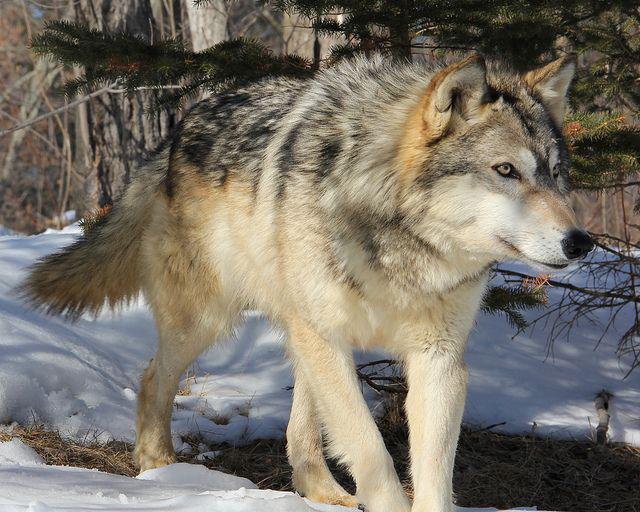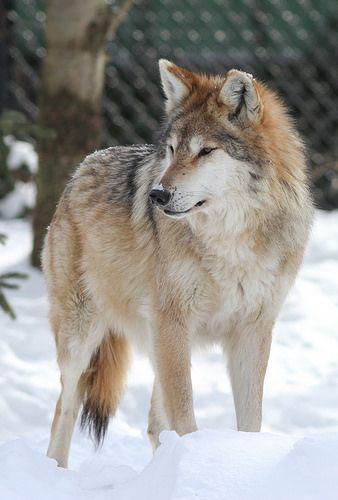The first image is the image on the left, the second image is the image on the right. Examine the images to the left and right. Is the description "The left-hand image shows a wolf that is not standing on all fours." accurate? Answer yes or no. No. 